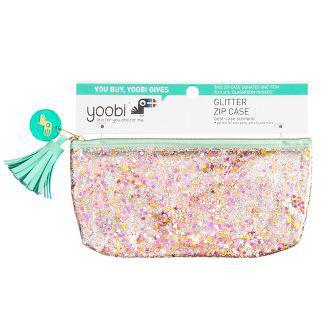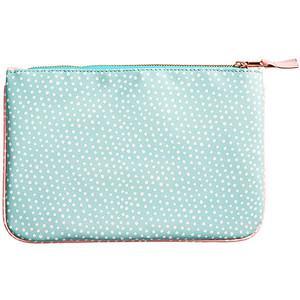The first image is the image on the left, the second image is the image on the right. Analyze the images presented: Is the assertion "The case on the left is more tube shaped than the flatter rectangular case on the right, and the case on the left has a bold print while the case on the right is monochromatic." valid? Answer yes or no. No. The first image is the image on the left, the second image is the image on the right. Analyze the images presented: Is the assertion "One of the images shows a blue bag with white polka dots." valid? Answer yes or no. Yes. 